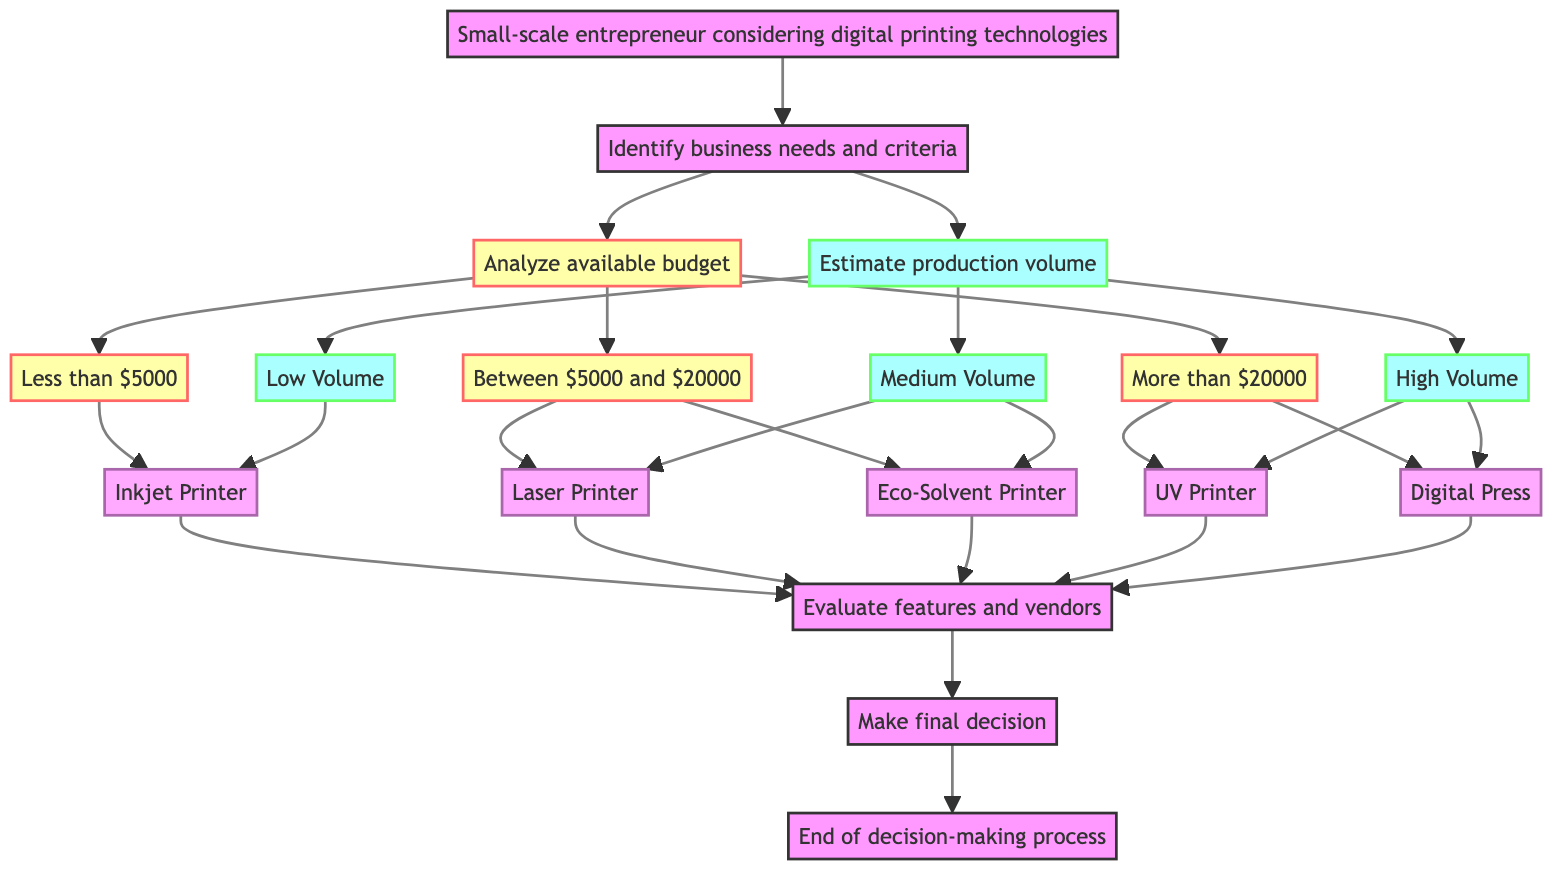What is the first step in the decision-making process? The diagram starts with the node labeled "Small-scale entrepreneur considering digital printing technologies." This is the initial step from where the process begins.
Answer: Start How many options are there for budget analysis? The "Budget Analysis" node has three branches leading to "Less Than 5000," "Between 5000 and 20000," and "More Than 20000," indicating three distinct budget options.
Answer: Three Which printing options are suggested for a production volume classified as "Medium"? The "Medium Volume" node has two subsequent options, "Laser Printer Option" and "Eco-Solvent Printer Option," indicating these are the suggested printing technologies for medium production volumes.
Answer: Laser Printer Option, Eco-Solvent Printer Option If the budget is "More Than 20000," which printing technologies will be evaluated next? From the "More Than 20000" node, the next options are "UV Printer Option" and "Digital Press Option," showing the choices under this budget category.
Answer: UV Printer Option, Digital Press Option What is the final step in the process? The last node before the "End" is "Make Final Decision," which indicates that this is where the decision is ultimately made before the process concludes.
Answer: Make Final Decision Which nodes lead to evaluating features and vendors? There are five nodes— "Inkjet Printer Option," "Laser Printer Option," "Eco-Solvent Printer Option," "UV Printer Option," and "Digital Press Option" —that all connect to "Evaluate Features And Vendors," indicating that all these options proceed to the evaluation stage.
Answer: Inkjet Printer Option, Laser Printer Option, Eco-Solvent Printer Option, UV Printer Option, Digital Press Option What determines the path from "Define Business Needs" to "Budget Analysis" or "Production Volume Assessment"? From the "Define Business Needs" node, the two branches go to "Budget Analysis" and "Production Volume Assessment," indicating that both budget and production volume are critical factors determined at this stage in decision-making.
Answer: Budget Analysis, Production Volume Assessment If the production volume is classified as "High," which printer options will be considered? The "High Volume" node leads to two options: "Digital Press Option" and "UV Printer Option," indicating these are the printing technologies recommended for high production volumes.
Answer: Digital Press Option, UV Printer Option 